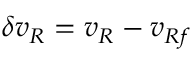Convert formula to latex. <formula><loc_0><loc_0><loc_500><loc_500>\delta { v _ { R } } = v _ { R } - v _ { R f }</formula> 